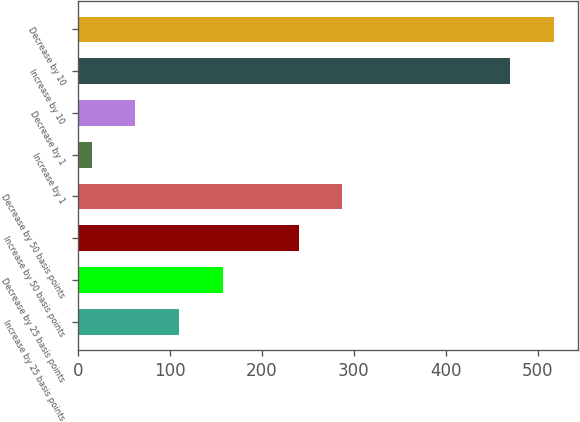Convert chart. <chart><loc_0><loc_0><loc_500><loc_500><bar_chart><fcel>Increase by 25 basis points<fcel>Decrease by 25 basis points<fcel>Increase by 50 basis points<fcel>Decrease by 50 basis points<fcel>Increase by 1<fcel>Decrease by 1<fcel>Increase by 10<fcel>Decrease by 10<nl><fcel>110<fcel>157.5<fcel>240<fcel>287.5<fcel>15<fcel>62.5<fcel>470<fcel>517.5<nl></chart> 